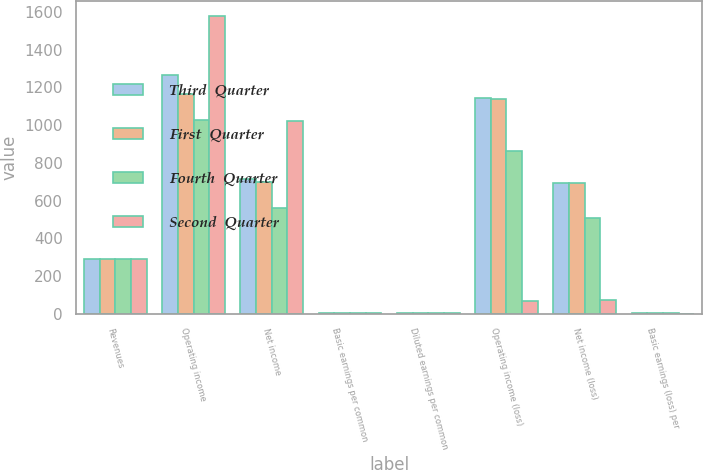<chart> <loc_0><loc_0><loc_500><loc_500><stacked_bar_chart><ecel><fcel>Revenues<fcel>Operating income<fcel>Net income<fcel>Basic earnings per common<fcel>Diluted earnings per common<fcel>Operating income (loss)<fcel>Net income (loss)<fcel>Basic earnings (loss) per<nl><fcel>Third  Quarter<fcel>288.5<fcel>1264<fcel>715<fcel>2.69<fcel>2.65<fcel>1144<fcel>692<fcel>2.45<nl><fcel>First  Quarter<fcel>288.5<fcel>1167<fcel>700<fcel>2.63<fcel>2.59<fcel>1137<fcel>691<fcel>2.47<nl><fcel>Fourth  Quarter<fcel>288.5<fcel>1025<fcel>562<fcel>2.11<fcel>2.07<fcel>864<fcel>507<fcel>1.86<nl><fcel>Second  Quarter<fcel>288.5<fcel>1581<fcel>1020<fcel>3.81<fcel>3.75<fcel>68<fcel>70<fcel>0.26<nl></chart> 